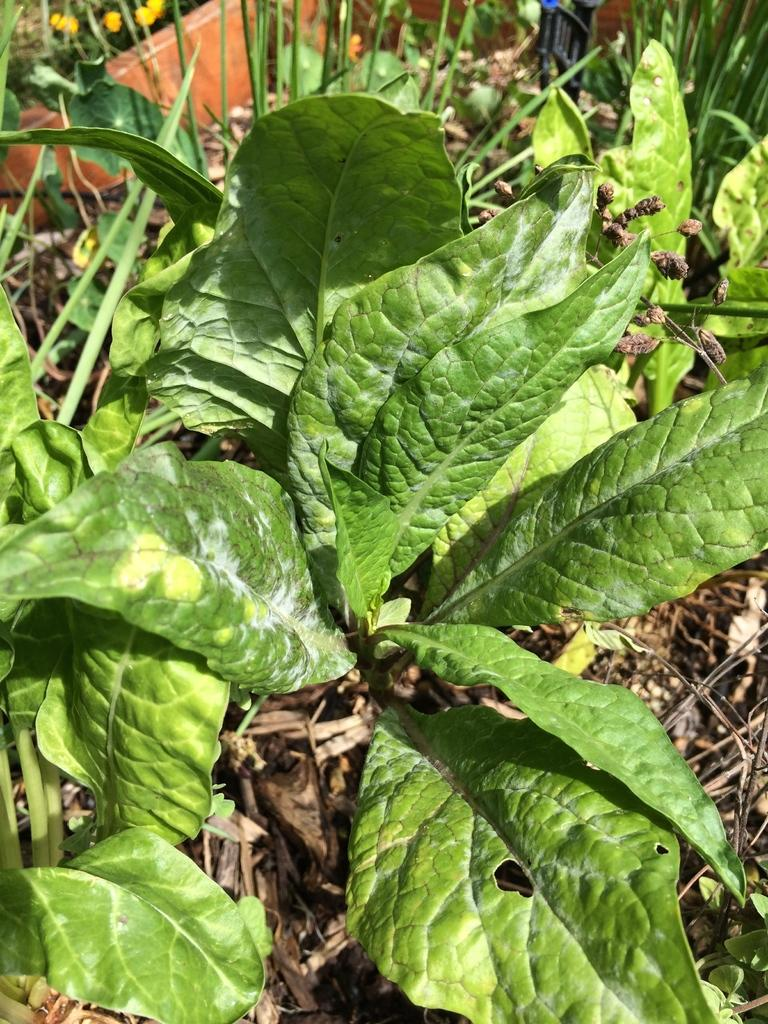What type of natural elements can be seen on the ground in the image? There are plants, dried leaves, and dried sticks on the ground in the image. What is the condition of the leaves and sticks on the ground? The leaves and sticks on the ground are dried. Where is the small wall located in the image? The small wall is in the top left corner of the image. What type of letters can be seen on the cave wall in the image? There is no cave or letters present in the image; it features plants, dried leaves, dried sticks, and a small wall. 